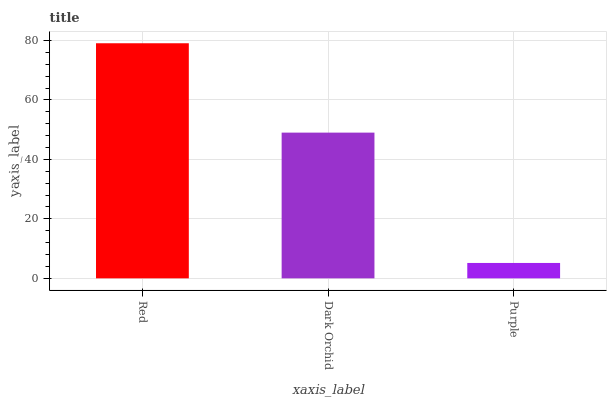Is Purple the minimum?
Answer yes or no. Yes. Is Red the maximum?
Answer yes or no. Yes. Is Dark Orchid the minimum?
Answer yes or no. No. Is Dark Orchid the maximum?
Answer yes or no. No. Is Red greater than Dark Orchid?
Answer yes or no. Yes. Is Dark Orchid less than Red?
Answer yes or no. Yes. Is Dark Orchid greater than Red?
Answer yes or no. No. Is Red less than Dark Orchid?
Answer yes or no. No. Is Dark Orchid the high median?
Answer yes or no. Yes. Is Dark Orchid the low median?
Answer yes or no. Yes. Is Purple the high median?
Answer yes or no. No. Is Red the low median?
Answer yes or no. No. 